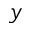Convert formula to latex. <formula><loc_0><loc_0><loc_500><loc_500>y</formula> 